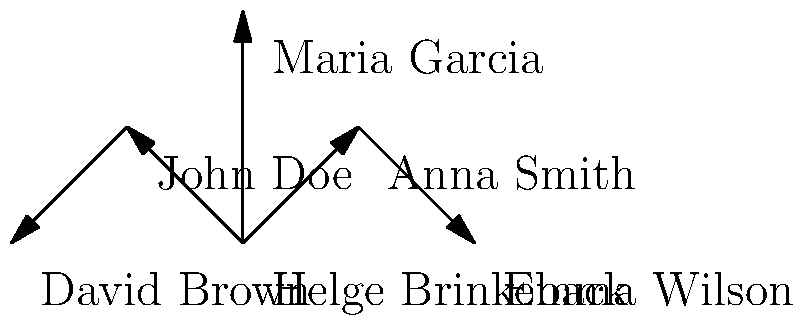Based on the network diagram showing Helge Brinkeback's research collaborations, how many direct collaborators does Brinkeback have, and who has the most extended network of secondary collaborators? To answer this question, we need to analyze the network diagram step by step:

1. Identify Helge Brinkeback's direct collaborators:
   - We can see arrows pointing from Brinkeback to Anna Smith, John Doe, and Maria Garcia.
   - This indicates that Brinkeback has 3 direct collaborators.

2. Examine the secondary collaborations:
   - Anna Smith has an arrow pointing to Emma Wilson, indicating a secondary collaboration.
   - John Doe has an arrow pointing to David Brown, indicating another secondary collaboration.
   - Maria Garcia has no arrows pointing to other researchers.

3. Compare the extended networks:
   - Anna Smith and John Doe both have one secondary collaborator each.
   - Maria Garcia has no secondary collaborators.

4. Determine who has the most extended network:
   - Since Anna Smith and John Doe both have one secondary collaborator, they are tied for the most extended network of secondary collaborators.

Therefore, Helge Brinkeback has 3 direct collaborators, and both Anna Smith and John Doe have the most extended network of secondary collaborators with one each.
Answer: 3 direct collaborators; Anna Smith and John Doe (tie) 